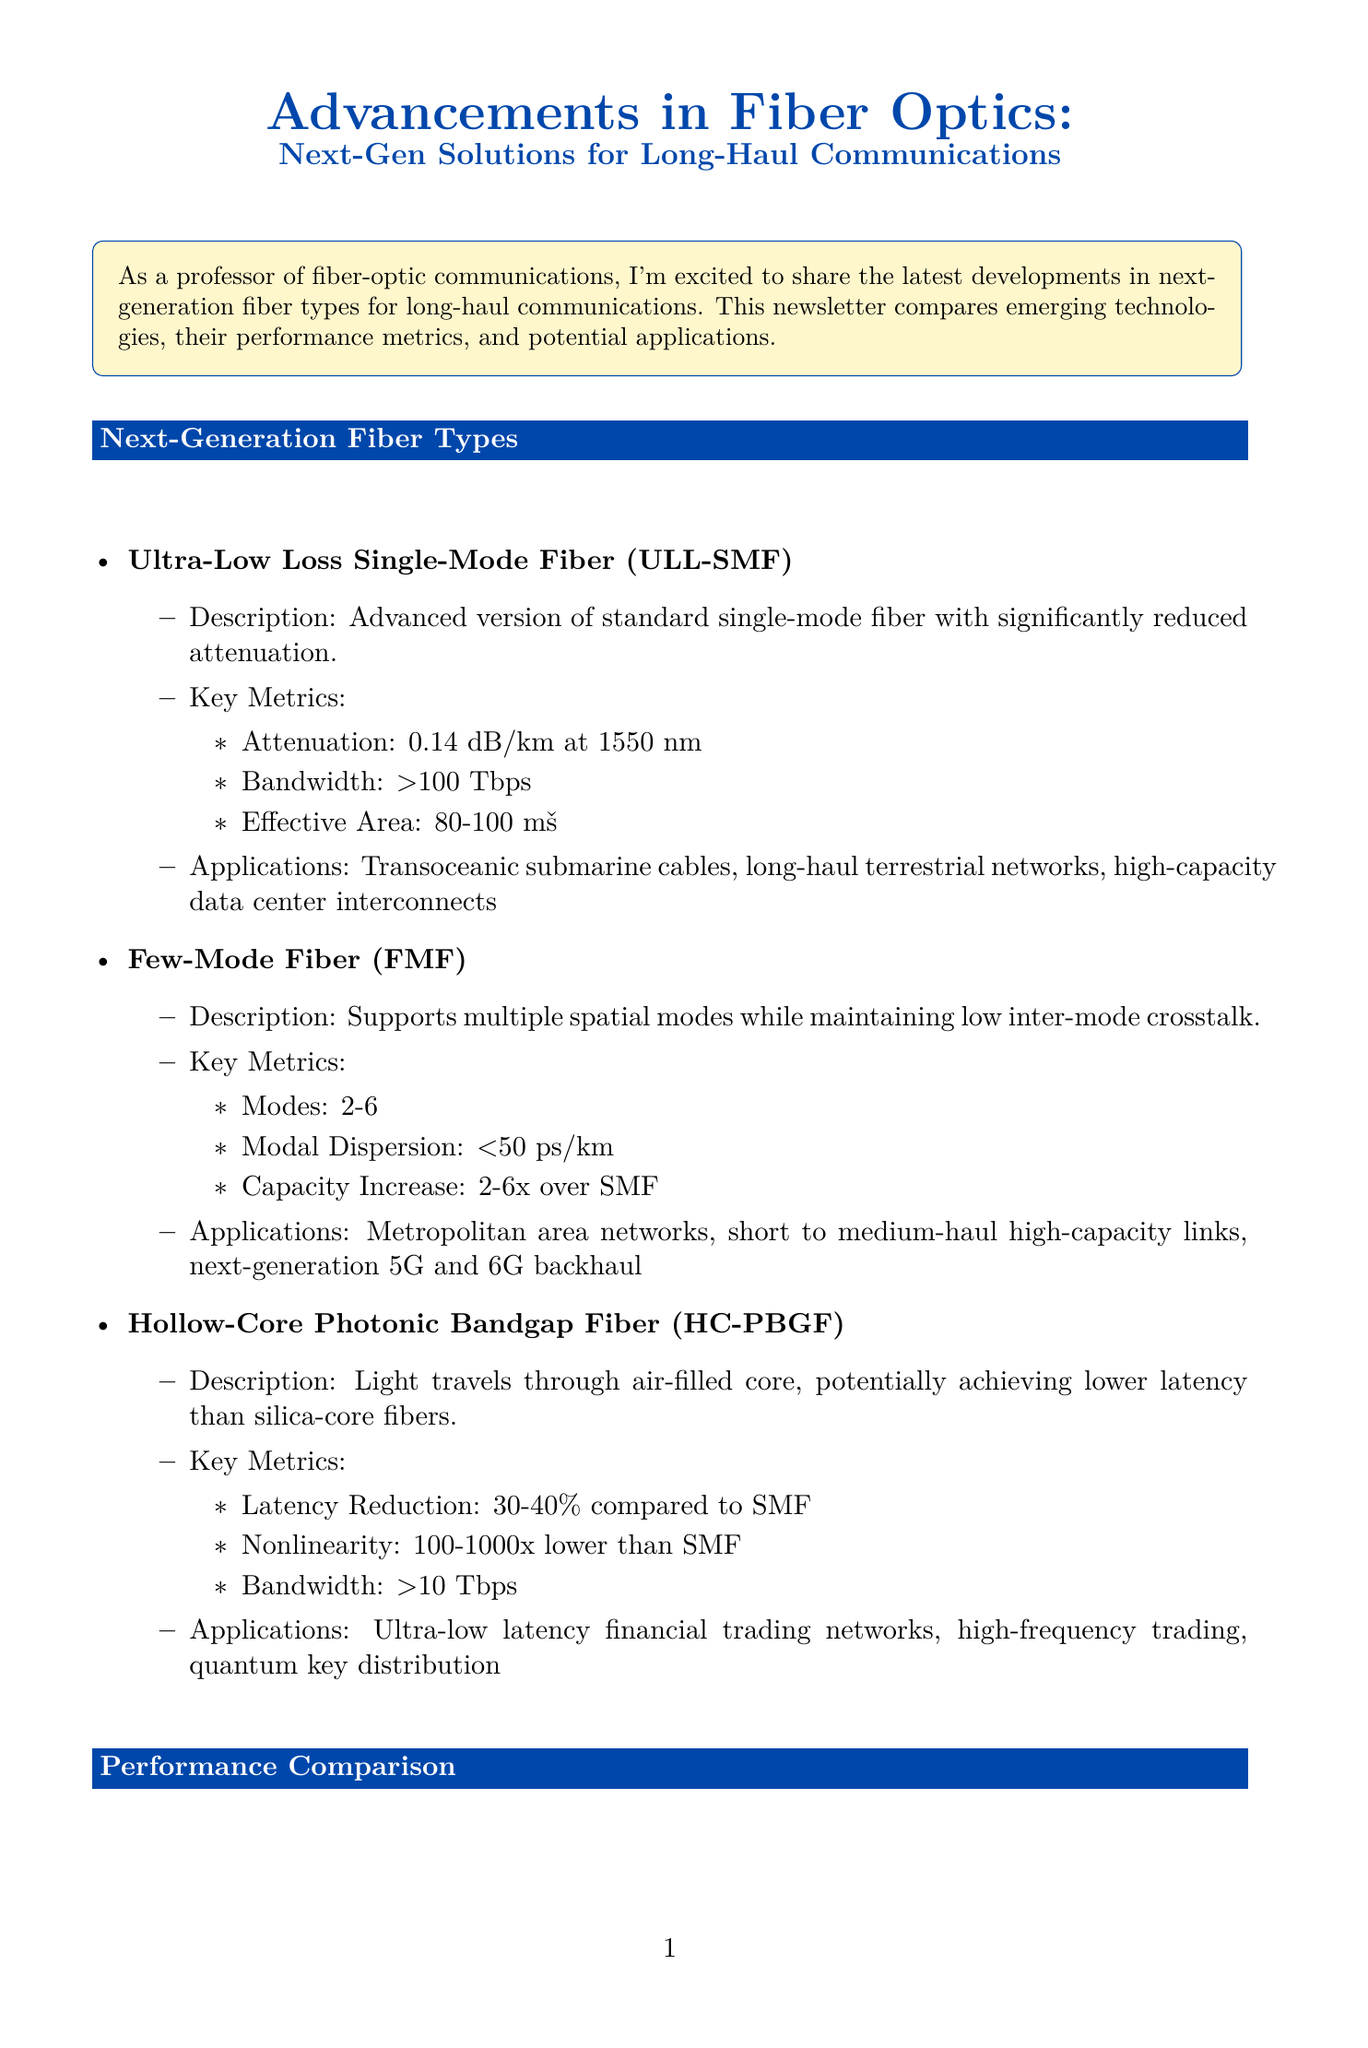What is the attenuation of ULL-SMF? The attenuation of ULL-SMF is specified in the document as 0.14 dB/km at 1550 nm.
Answer: 0.14 dB/km How many modes can Few-Mode Fiber (FMF) support? The document states that Few-Mode Fiber (FMF) supports between 2 to 6 modes.
Answer: 2-6 What is the bandwidth of Hollow-Core Photonic Bandgap Fiber (HC-PBGF)? The document mentions that the bandwidth of HC-PBGF is greater than 10 Tbps.
Answer: >10 Tbps Which company produces the SMF-28 ULL Optical Fiber? The document identifies Corning as the producer of the SMF-28 ULL Optical Fiber.
Answer: Corning How does HC-PBGF compare in latency to standard single-mode fiber? The document notes that HC-PBGF has a latency reduction of 30-40% compared to standard single-mode fiber.
Answer: 30-40% What could the breakthrough in multi-core fiber design potentially enable? The document states that this breakthrough could potentially enable petabit-scale transmission over a single fiber.
Answer: Petabit-scale transmission What is the primary application area for ULL-SMF? The applications listed for ULL-SMF include transoceanic submarine cables, which indicates its primary application area.
Answer: Transoceanic submarine cables What is the modal dispersion of Few-Mode Fiber (FMF)? The modal dispersion of FMF is specified in the document as less than 50 ps/km.
Answer: <50 ps/km 